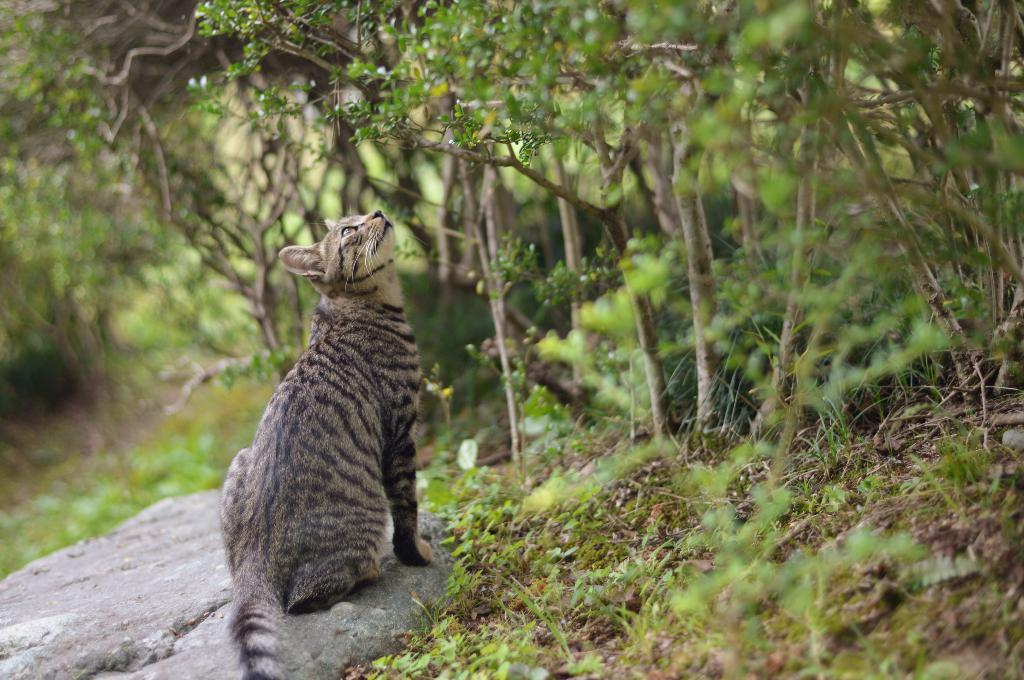What animal is present in the image? There is a cat in the image. Where is the cat sitting? The cat is sitting on a stone. What type of vegetation can be seen in the background? Plants, trees, and grass are visible in the background. How many snakes are coiled around the cat in the image? There are no snakes present in the image; it features a cat sitting on a stone. What type of visitor can be seen interacting with the cat in the image? There is no visitor present in the image; it only features a cat sitting on a stone. 